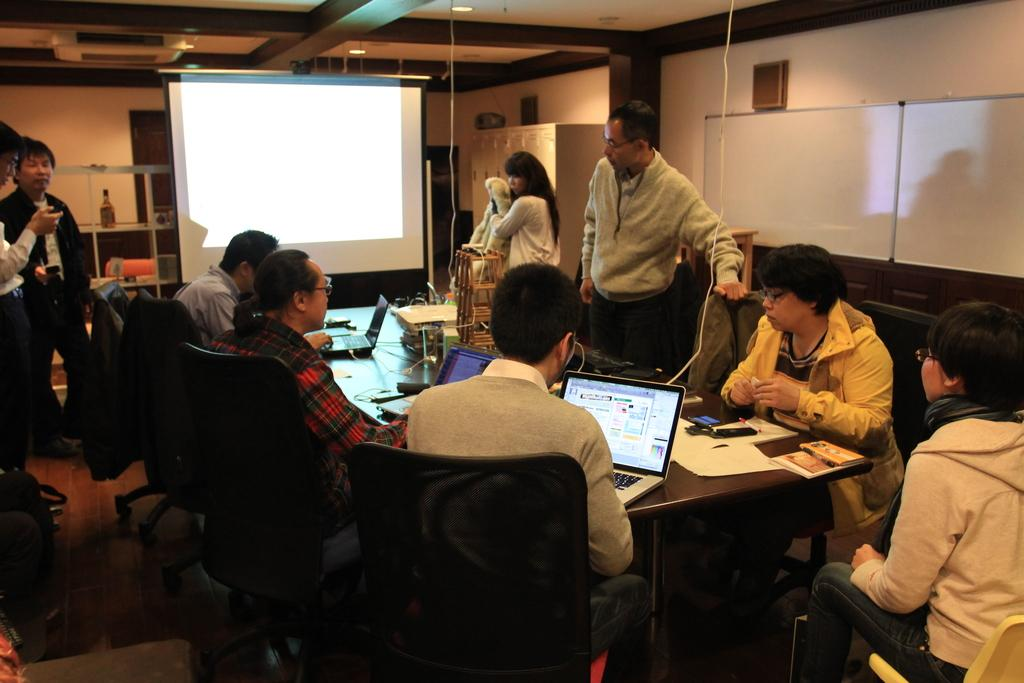How many people are in the image? There is a group of people in the image, but the exact number is not specified. What are the people doing in the image? The people are sitting around a table in the image. What objects can be seen on the table? There are laptops on the table in the image. What is in front of the people? There is a big screen in front of the people in the image. What type of patch is sewn onto the metal stem in the image? There is no patch or metal stem present in the image. 